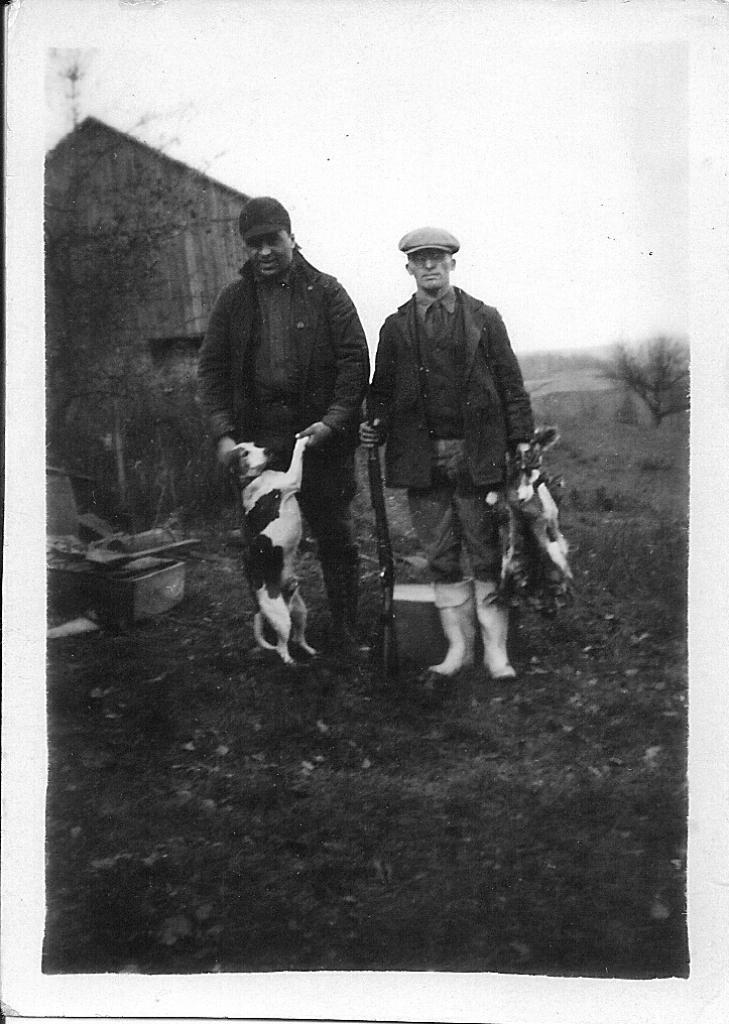What is the man in the image doing with the dog? The man is standing and holding a dog in the image. Can you describe the other man in the image? There is another man standing by holding an animal in the image. What can be seen in the background of the image? There is a house, a tree, grass, and sky visible in the background of the image. What type of thumb can be seen in the image? There is no thumb present in the image. Can you describe the nest in the image? There is no nest present in the image. 